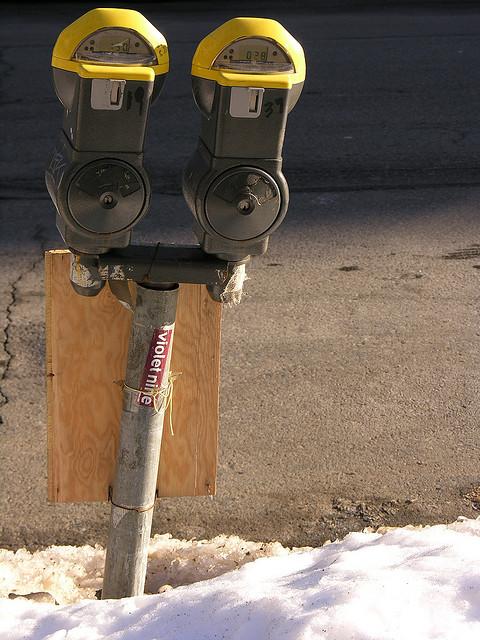Is the snow melting?
Answer briefly. Yes. How much is the meter?
Quick response, please. 25 cents. What color is the meter?
Write a very short answer. Black and yellow. What is written on the meter?
Write a very short answer. Violet 9. Is there still time on both the meters?
Keep it brief. No. Is any of the snow in this picture dirty?
Quick response, please. Yes. 